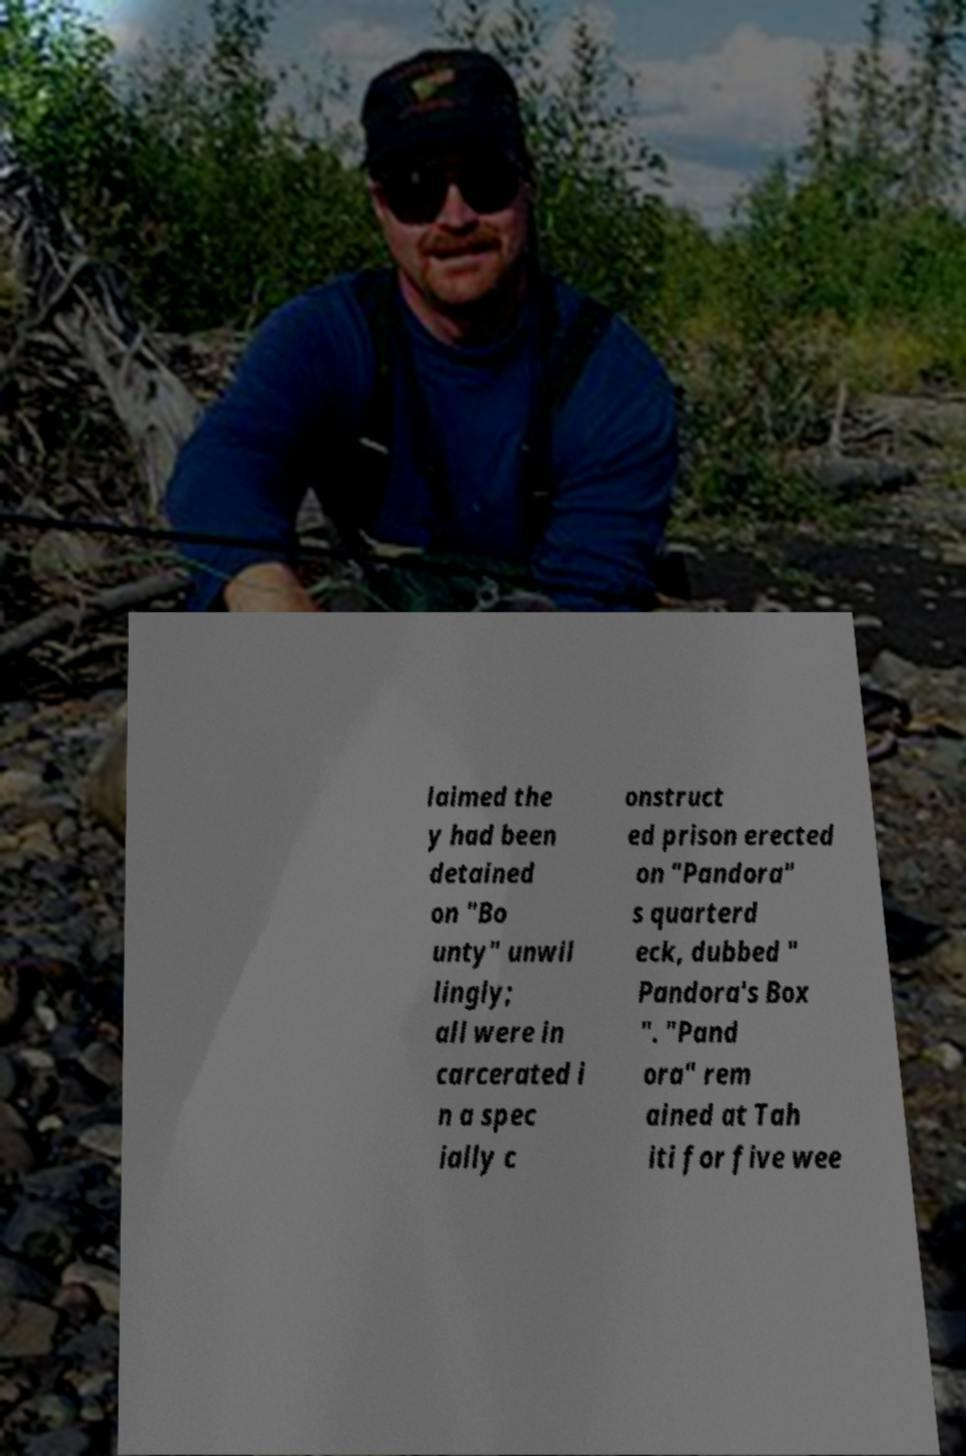For documentation purposes, I need the text within this image transcribed. Could you provide that? laimed the y had been detained on "Bo unty" unwil lingly; all were in carcerated i n a spec ially c onstruct ed prison erected on "Pandora" s quarterd eck, dubbed " Pandora's Box ". "Pand ora" rem ained at Tah iti for five wee 